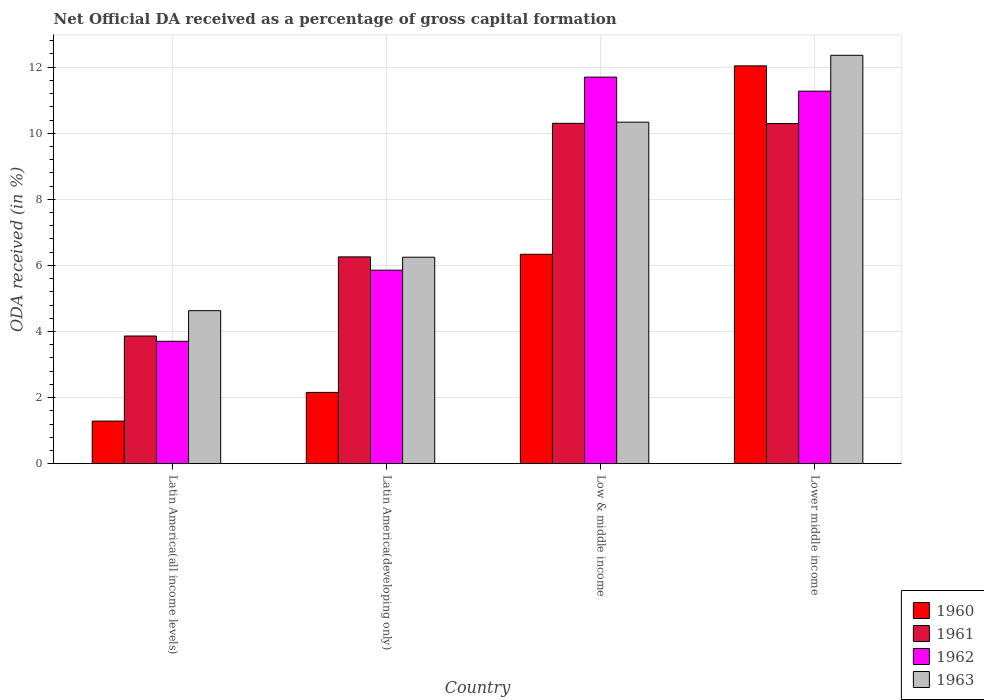How many groups of bars are there?
Your response must be concise. 4. Are the number of bars per tick equal to the number of legend labels?
Give a very brief answer. Yes. How many bars are there on the 4th tick from the left?
Make the answer very short. 4. What is the label of the 3rd group of bars from the left?
Make the answer very short. Low & middle income. In how many cases, is the number of bars for a given country not equal to the number of legend labels?
Offer a terse response. 0. What is the net ODA received in 1963 in Low & middle income?
Your answer should be very brief. 10.33. Across all countries, what is the maximum net ODA received in 1960?
Provide a succinct answer. 12.04. Across all countries, what is the minimum net ODA received in 1963?
Your answer should be very brief. 4.63. In which country was the net ODA received in 1960 maximum?
Your answer should be very brief. Lower middle income. In which country was the net ODA received in 1961 minimum?
Your response must be concise. Latin America(all income levels). What is the total net ODA received in 1961 in the graph?
Your answer should be compact. 30.71. What is the difference between the net ODA received in 1963 in Latin America(all income levels) and that in Lower middle income?
Your response must be concise. -7.73. What is the difference between the net ODA received in 1961 in Lower middle income and the net ODA received in 1960 in Latin America(all income levels)?
Ensure brevity in your answer.  9. What is the average net ODA received in 1962 per country?
Offer a terse response. 8.13. What is the difference between the net ODA received of/in 1962 and net ODA received of/in 1961 in Low & middle income?
Keep it short and to the point. 1.4. What is the ratio of the net ODA received in 1962 in Latin America(developing only) to that in Low & middle income?
Provide a short and direct response. 0.5. Is the net ODA received in 1961 in Latin America(all income levels) less than that in Lower middle income?
Provide a succinct answer. Yes. What is the difference between the highest and the second highest net ODA received in 1963?
Your answer should be compact. -2.02. What is the difference between the highest and the lowest net ODA received in 1963?
Your response must be concise. 7.73. In how many countries, is the net ODA received in 1963 greater than the average net ODA received in 1963 taken over all countries?
Your answer should be compact. 2. What does the 4th bar from the left in Latin America(developing only) represents?
Ensure brevity in your answer.  1963. What does the 1st bar from the right in Latin America(developing only) represents?
Offer a very short reply. 1963. Is it the case that in every country, the sum of the net ODA received in 1963 and net ODA received in 1962 is greater than the net ODA received in 1961?
Keep it short and to the point. Yes. What is the difference between two consecutive major ticks on the Y-axis?
Ensure brevity in your answer.  2. Are the values on the major ticks of Y-axis written in scientific E-notation?
Offer a terse response. No. Does the graph contain any zero values?
Your response must be concise. No. Does the graph contain grids?
Your answer should be compact. Yes. How many legend labels are there?
Make the answer very short. 4. What is the title of the graph?
Give a very brief answer. Net Official DA received as a percentage of gross capital formation. What is the label or title of the Y-axis?
Ensure brevity in your answer.  ODA received (in %). What is the ODA received (in %) of 1960 in Latin America(all income levels)?
Offer a terse response. 1.29. What is the ODA received (in %) in 1961 in Latin America(all income levels)?
Provide a short and direct response. 3.86. What is the ODA received (in %) of 1962 in Latin America(all income levels)?
Ensure brevity in your answer.  3.7. What is the ODA received (in %) in 1963 in Latin America(all income levels)?
Offer a very short reply. 4.63. What is the ODA received (in %) in 1960 in Latin America(developing only)?
Provide a short and direct response. 2.16. What is the ODA received (in %) in 1961 in Latin America(developing only)?
Your response must be concise. 6.26. What is the ODA received (in %) in 1962 in Latin America(developing only)?
Provide a succinct answer. 5.86. What is the ODA received (in %) of 1963 in Latin America(developing only)?
Ensure brevity in your answer.  6.25. What is the ODA received (in %) of 1960 in Low & middle income?
Keep it short and to the point. 6.34. What is the ODA received (in %) in 1961 in Low & middle income?
Offer a very short reply. 10.3. What is the ODA received (in %) in 1962 in Low & middle income?
Provide a short and direct response. 11.7. What is the ODA received (in %) in 1963 in Low & middle income?
Give a very brief answer. 10.33. What is the ODA received (in %) in 1960 in Lower middle income?
Make the answer very short. 12.04. What is the ODA received (in %) in 1961 in Lower middle income?
Offer a terse response. 10.29. What is the ODA received (in %) in 1962 in Lower middle income?
Give a very brief answer. 11.27. What is the ODA received (in %) of 1963 in Lower middle income?
Provide a succinct answer. 12.36. Across all countries, what is the maximum ODA received (in %) of 1960?
Ensure brevity in your answer.  12.04. Across all countries, what is the maximum ODA received (in %) of 1961?
Your answer should be very brief. 10.3. Across all countries, what is the maximum ODA received (in %) in 1962?
Your answer should be compact. 11.7. Across all countries, what is the maximum ODA received (in %) of 1963?
Provide a succinct answer. 12.36. Across all countries, what is the minimum ODA received (in %) of 1960?
Offer a very short reply. 1.29. Across all countries, what is the minimum ODA received (in %) in 1961?
Offer a terse response. 3.86. Across all countries, what is the minimum ODA received (in %) of 1962?
Keep it short and to the point. 3.7. Across all countries, what is the minimum ODA received (in %) of 1963?
Ensure brevity in your answer.  4.63. What is the total ODA received (in %) of 1960 in the graph?
Offer a terse response. 21.82. What is the total ODA received (in %) in 1961 in the graph?
Your answer should be compact. 30.71. What is the total ODA received (in %) of 1962 in the graph?
Offer a very short reply. 32.53. What is the total ODA received (in %) of 1963 in the graph?
Ensure brevity in your answer.  33.57. What is the difference between the ODA received (in %) in 1960 in Latin America(all income levels) and that in Latin America(developing only)?
Your response must be concise. -0.87. What is the difference between the ODA received (in %) of 1961 in Latin America(all income levels) and that in Latin America(developing only)?
Offer a terse response. -2.39. What is the difference between the ODA received (in %) in 1962 in Latin America(all income levels) and that in Latin America(developing only)?
Your response must be concise. -2.15. What is the difference between the ODA received (in %) in 1963 in Latin America(all income levels) and that in Latin America(developing only)?
Your response must be concise. -1.62. What is the difference between the ODA received (in %) of 1960 in Latin America(all income levels) and that in Low & middle income?
Your answer should be compact. -5.05. What is the difference between the ODA received (in %) of 1961 in Latin America(all income levels) and that in Low & middle income?
Your answer should be very brief. -6.43. What is the difference between the ODA received (in %) of 1962 in Latin America(all income levels) and that in Low & middle income?
Offer a terse response. -7.99. What is the difference between the ODA received (in %) in 1963 in Latin America(all income levels) and that in Low & middle income?
Your response must be concise. -5.7. What is the difference between the ODA received (in %) of 1960 in Latin America(all income levels) and that in Lower middle income?
Give a very brief answer. -10.75. What is the difference between the ODA received (in %) in 1961 in Latin America(all income levels) and that in Lower middle income?
Give a very brief answer. -6.43. What is the difference between the ODA received (in %) of 1962 in Latin America(all income levels) and that in Lower middle income?
Make the answer very short. -7.57. What is the difference between the ODA received (in %) in 1963 in Latin America(all income levels) and that in Lower middle income?
Offer a very short reply. -7.73. What is the difference between the ODA received (in %) in 1960 in Latin America(developing only) and that in Low & middle income?
Your response must be concise. -4.18. What is the difference between the ODA received (in %) of 1961 in Latin America(developing only) and that in Low & middle income?
Ensure brevity in your answer.  -4.04. What is the difference between the ODA received (in %) of 1962 in Latin America(developing only) and that in Low & middle income?
Provide a succinct answer. -5.84. What is the difference between the ODA received (in %) of 1963 in Latin America(developing only) and that in Low & middle income?
Your answer should be compact. -4.09. What is the difference between the ODA received (in %) of 1960 in Latin America(developing only) and that in Lower middle income?
Offer a terse response. -9.88. What is the difference between the ODA received (in %) in 1961 in Latin America(developing only) and that in Lower middle income?
Your response must be concise. -4.03. What is the difference between the ODA received (in %) of 1962 in Latin America(developing only) and that in Lower middle income?
Give a very brief answer. -5.42. What is the difference between the ODA received (in %) of 1963 in Latin America(developing only) and that in Lower middle income?
Keep it short and to the point. -6.11. What is the difference between the ODA received (in %) in 1960 in Low & middle income and that in Lower middle income?
Keep it short and to the point. -5.7. What is the difference between the ODA received (in %) of 1961 in Low & middle income and that in Lower middle income?
Your answer should be very brief. 0.01. What is the difference between the ODA received (in %) in 1962 in Low & middle income and that in Lower middle income?
Provide a succinct answer. 0.43. What is the difference between the ODA received (in %) of 1963 in Low & middle income and that in Lower middle income?
Ensure brevity in your answer.  -2.02. What is the difference between the ODA received (in %) in 1960 in Latin America(all income levels) and the ODA received (in %) in 1961 in Latin America(developing only)?
Make the answer very short. -4.97. What is the difference between the ODA received (in %) in 1960 in Latin America(all income levels) and the ODA received (in %) in 1962 in Latin America(developing only)?
Ensure brevity in your answer.  -4.57. What is the difference between the ODA received (in %) of 1960 in Latin America(all income levels) and the ODA received (in %) of 1963 in Latin America(developing only)?
Provide a succinct answer. -4.96. What is the difference between the ODA received (in %) of 1961 in Latin America(all income levels) and the ODA received (in %) of 1962 in Latin America(developing only)?
Offer a terse response. -1.99. What is the difference between the ODA received (in %) in 1961 in Latin America(all income levels) and the ODA received (in %) in 1963 in Latin America(developing only)?
Make the answer very short. -2.38. What is the difference between the ODA received (in %) of 1962 in Latin America(all income levels) and the ODA received (in %) of 1963 in Latin America(developing only)?
Provide a succinct answer. -2.54. What is the difference between the ODA received (in %) of 1960 in Latin America(all income levels) and the ODA received (in %) of 1961 in Low & middle income?
Your answer should be compact. -9.01. What is the difference between the ODA received (in %) in 1960 in Latin America(all income levels) and the ODA received (in %) in 1962 in Low & middle income?
Ensure brevity in your answer.  -10.41. What is the difference between the ODA received (in %) in 1960 in Latin America(all income levels) and the ODA received (in %) in 1963 in Low & middle income?
Ensure brevity in your answer.  -9.04. What is the difference between the ODA received (in %) in 1961 in Latin America(all income levels) and the ODA received (in %) in 1962 in Low & middle income?
Provide a succinct answer. -7.83. What is the difference between the ODA received (in %) of 1961 in Latin America(all income levels) and the ODA received (in %) of 1963 in Low & middle income?
Your answer should be very brief. -6.47. What is the difference between the ODA received (in %) of 1962 in Latin America(all income levels) and the ODA received (in %) of 1963 in Low & middle income?
Your answer should be compact. -6.63. What is the difference between the ODA received (in %) in 1960 in Latin America(all income levels) and the ODA received (in %) in 1961 in Lower middle income?
Provide a short and direct response. -9. What is the difference between the ODA received (in %) of 1960 in Latin America(all income levels) and the ODA received (in %) of 1962 in Lower middle income?
Provide a succinct answer. -9.98. What is the difference between the ODA received (in %) of 1960 in Latin America(all income levels) and the ODA received (in %) of 1963 in Lower middle income?
Provide a succinct answer. -11.07. What is the difference between the ODA received (in %) in 1961 in Latin America(all income levels) and the ODA received (in %) in 1962 in Lower middle income?
Offer a terse response. -7.41. What is the difference between the ODA received (in %) in 1961 in Latin America(all income levels) and the ODA received (in %) in 1963 in Lower middle income?
Your answer should be very brief. -8.49. What is the difference between the ODA received (in %) in 1962 in Latin America(all income levels) and the ODA received (in %) in 1963 in Lower middle income?
Make the answer very short. -8.65. What is the difference between the ODA received (in %) in 1960 in Latin America(developing only) and the ODA received (in %) in 1961 in Low & middle income?
Ensure brevity in your answer.  -8.14. What is the difference between the ODA received (in %) of 1960 in Latin America(developing only) and the ODA received (in %) of 1962 in Low & middle income?
Provide a succinct answer. -9.54. What is the difference between the ODA received (in %) in 1960 in Latin America(developing only) and the ODA received (in %) in 1963 in Low & middle income?
Provide a short and direct response. -8.18. What is the difference between the ODA received (in %) of 1961 in Latin America(developing only) and the ODA received (in %) of 1962 in Low & middle income?
Your response must be concise. -5.44. What is the difference between the ODA received (in %) of 1961 in Latin America(developing only) and the ODA received (in %) of 1963 in Low & middle income?
Keep it short and to the point. -4.08. What is the difference between the ODA received (in %) of 1962 in Latin America(developing only) and the ODA received (in %) of 1963 in Low & middle income?
Offer a very short reply. -4.48. What is the difference between the ODA received (in %) of 1960 in Latin America(developing only) and the ODA received (in %) of 1961 in Lower middle income?
Provide a short and direct response. -8.13. What is the difference between the ODA received (in %) in 1960 in Latin America(developing only) and the ODA received (in %) in 1962 in Lower middle income?
Give a very brief answer. -9.11. What is the difference between the ODA received (in %) in 1960 in Latin America(developing only) and the ODA received (in %) in 1963 in Lower middle income?
Keep it short and to the point. -10.2. What is the difference between the ODA received (in %) of 1961 in Latin America(developing only) and the ODA received (in %) of 1962 in Lower middle income?
Offer a terse response. -5.01. What is the difference between the ODA received (in %) of 1961 in Latin America(developing only) and the ODA received (in %) of 1963 in Lower middle income?
Keep it short and to the point. -6.1. What is the difference between the ODA received (in %) in 1962 in Latin America(developing only) and the ODA received (in %) in 1963 in Lower middle income?
Make the answer very short. -6.5. What is the difference between the ODA received (in %) in 1960 in Low & middle income and the ODA received (in %) in 1961 in Lower middle income?
Your response must be concise. -3.96. What is the difference between the ODA received (in %) of 1960 in Low & middle income and the ODA received (in %) of 1962 in Lower middle income?
Your response must be concise. -4.93. What is the difference between the ODA received (in %) in 1960 in Low & middle income and the ODA received (in %) in 1963 in Lower middle income?
Keep it short and to the point. -6.02. What is the difference between the ODA received (in %) of 1961 in Low & middle income and the ODA received (in %) of 1962 in Lower middle income?
Your answer should be very brief. -0.97. What is the difference between the ODA received (in %) in 1961 in Low & middle income and the ODA received (in %) in 1963 in Lower middle income?
Provide a succinct answer. -2.06. What is the difference between the ODA received (in %) of 1962 in Low & middle income and the ODA received (in %) of 1963 in Lower middle income?
Make the answer very short. -0.66. What is the average ODA received (in %) in 1960 per country?
Offer a terse response. 5.46. What is the average ODA received (in %) of 1961 per country?
Make the answer very short. 7.68. What is the average ODA received (in %) of 1962 per country?
Give a very brief answer. 8.13. What is the average ODA received (in %) of 1963 per country?
Offer a very short reply. 8.39. What is the difference between the ODA received (in %) of 1960 and ODA received (in %) of 1961 in Latin America(all income levels)?
Offer a very short reply. -2.57. What is the difference between the ODA received (in %) in 1960 and ODA received (in %) in 1962 in Latin America(all income levels)?
Your answer should be compact. -2.41. What is the difference between the ODA received (in %) of 1960 and ODA received (in %) of 1963 in Latin America(all income levels)?
Ensure brevity in your answer.  -3.34. What is the difference between the ODA received (in %) of 1961 and ODA received (in %) of 1962 in Latin America(all income levels)?
Your answer should be very brief. 0.16. What is the difference between the ODA received (in %) in 1961 and ODA received (in %) in 1963 in Latin America(all income levels)?
Make the answer very short. -0.77. What is the difference between the ODA received (in %) of 1962 and ODA received (in %) of 1963 in Latin America(all income levels)?
Ensure brevity in your answer.  -0.93. What is the difference between the ODA received (in %) in 1960 and ODA received (in %) in 1962 in Latin America(developing only)?
Provide a succinct answer. -3.7. What is the difference between the ODA received (in %) in 1960 and ODA received (in %) in 1963 in Latin America(developing only)?
Your response must be concise. -4.09. What is the difference between the ODA received (in %) of 1961 and ODA received (in %) of 1962 in Latin America(developing only)?
Ensure brevity in your answer.  0.4. What is the difference between the ODA received (in %) of 1961 and ODA received (in %) of 1963 in Latin America(developing only)?
Offer a terse response. 0.01. What is the difference between the ODA received (in %) of 1962 and ODA received (in %) of 1963 in Latin America(developing only)?
Make the answer very short. -0.39. What is the difference between the ODA received (in %) of 1960 and ODA received (in %) of 1961 in Low & middle income?
Make the answer very short. -3.96. What is the difference between the ODA received (in %) in 1960 and ODA received (in %) in 1962 in Low & middle income?
Keep it short and to the point. -5.36. What is the difference between the ODA received (in %) of 1960 and ODA received (in %) of 1963 in Low & middle income?
Your answer should be very brief. -4. What is the difference between the ODA received (in %) of 1961 and ODA received (in %) of 1962 in Low & middle income?
Offer a terse response. -1.4. What is the difference between the ODA received (in %) in 1961 and ODA received (in %) in 1963 in Low & middle income?
Ensure brevity in your answer.  -0.03. What is the difference between the ODA received (in %) of 1962 and ODA received (in %) of 1963 in Low & middle income?
Your response must be concise. 1.36. What is the difference between the ODA received (in %) in 1960 and ODA received (in %) in 1961 in Lower middle income?
Give a very brief answer. 1.75. What is the difference between the ODA received (in %) of 1960 and ODA received (in %) of 1962 in Lower middle income?
Give a very brief answer. 0.77. What is the difference between the ODA received (in %) in 1960 and ODA received (in %) in 1963 in Lower middle income?
Offer a very short reply. -0.32. What is the difference between the ODA received (in %) of 1961 and ODA received (in %) of 1962 in Lower middle income?
Provide a succinct answer. -0.98. What is the difference between the ODA received (in %) in 1961 and ODA received (in %) in 1963 in Lower middle income?
Offer a terse response. -2.07. What is the difference between the ODA received (in %) of 1962 and ODA received (in %) of 1963 in Lower middle income?
Provide a short and direct response. -1.09. What is the ratio of the ODA received (in %) of 1960 in Latin America(all income levels) to that in Latin America(developing only)?
Offer a very short reply. 0.6. What is the ratio of the ODA received (in %) in 1961 in Latin America(all income levels) to that in Latin America(developing only)?
Give a very brief answer. 0.62. What is the ratio of the ODA received (in %) of 1962 in Latin America(all income levels) to that in Latin America(developing only)?
Your response must be concise. 0.63. What is the ratio of the ODA received (in %) in 1963 in Latin America(all income levels) to that in Latin America(developing only)?
Offer a very short reply. 0.74. What is the ratio of the ODA received (in %) in 1960 in Latin America(all income levels) to that in Low & middle income?
Offer a terse response. 0.2. What is the ratio of the ODA received (in %) in 1961 in Latin America(all income levels) to that in Low & middle income?
Offer a terse response. 0.38. What is the ratio of the ODA received (in %) in 1962 in Latin America(all income levels) to that in Low & middle income?
Ensure brevity in your answer.  0.32. What is the ratio of the ODA received (in %) of 1963 in Latin America(all income levels) to that in Low & middle income?
Your response must be concise. 0.45. What is the ratio of the ODA received (in %) in 1960 in Latin America(all income levels) to that in Lower middle income?
Your answer should be compact. 0.11. What is the ratio of the ODA received (in %) in 1961 in Latin America(all income levels) to that in Lower middle income?
Make the answer very short. 0.38. What is the ratio of the ODA received (in %) in 1962 in Latin America(all income levels) to that in Lower middle income?
Offer a very short reply. 0.33. What is the ratio of the ODA received (in %) of 1963 in Latin America(all income levels) to that in Lower middle income?
Offer a very short reply. 0.37. What is the ratio of the ODA received (in %) of 1960 in Latin America(developing only) to that in Low & middle income?
Offer a terse response. 0.34. What is the ratio of the ODA received (in %) in 1961 in Latin America(developing only) to that in Low & middle income?
Your answer should be very brief. 0.61. What is the ratio of the ODA received (in %) of 1962 in Latin America(developing only) to that in Low & middle income?
Make the answer very short. 0.5. What is the ratio of the ODA received (in %) of 1963 in Latin America(developing only) to that in Low & middle income?
Your response must be concise. 0.6. What is the ratio of the ODA received (in %) in 1960 in Latin America(developing only) to that in Lower middle income?
Make the answer very short. 0.18. What is the ratio of the ODA received (in %) in 1961 in Latin America(developing only) to that in Lower middle income?
Provide a short and direct response. 0.61. What is the ratio of the ODA received (in %) of 1962 in Latin America(developing only) to that in Lower middle income?
Provide a succinct answer. 0.52. What is the ratio of the ODA received (in %) of 1963 in Latin America(developing only) to that in Lower middle income?
Your answer should be very brief. 0.51. What is the ratio of the ODA received (in %) in 1960 in Low & middle income to that in Lower middle income?
Your response must be concise. 0.53. What is the ratio of the ODA received (in %) of 1961 in Low & middle income to that in Lower middle income?
Provide a short and direct response. 1. What is the ratio of the ODA received (in %) in 1962 in Low & middle income to that in Lower middle income?
Provide a succinct answer. 1.04. What is the ratio of the ODA received (in %) of 1963 in Low & middle income to that in Lower middle income?
Make the answer very short. 0.84. What is the difference between the highest and the second highest ODA received (in %) of 1960?
Ensure brevity in your answer.  5.7. What is the difference between the highest and the second highest ODA received (in %) in 1961?
Provide a succinct answer. 0.01. What is the difference between the highest and the second highest ODA received (in %) of 1962?
Your response must be concise. 0.43. What is the difference between the highest and the second highest ODA received (in %) of 1963?
Your answer should be compact. 2.02. What is the difference between the highest and the lowest ODA received (in %) of 1960?
Give a very brief answer. 10.75. What is the difference between the highest and the lowest ODA received (in %) of 1961?
Give a very brief answer. 6.43. What is the difference between the highest and the lowest ODA received (in %) of 1962?
Your answer should be very brief. 7.99. What is the difference between the highest and the lowest ODA received (in %) in 1963?
Your response must be concise. 7.73. 